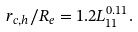Convert formula to latex. <formula><loc_0><loc_0><loc_500><loc_500>r _ { c , h } / R _ { e } = 1 . 2 L _ { 1 1 } ^ { 0 . 1 1 } .</formula> 